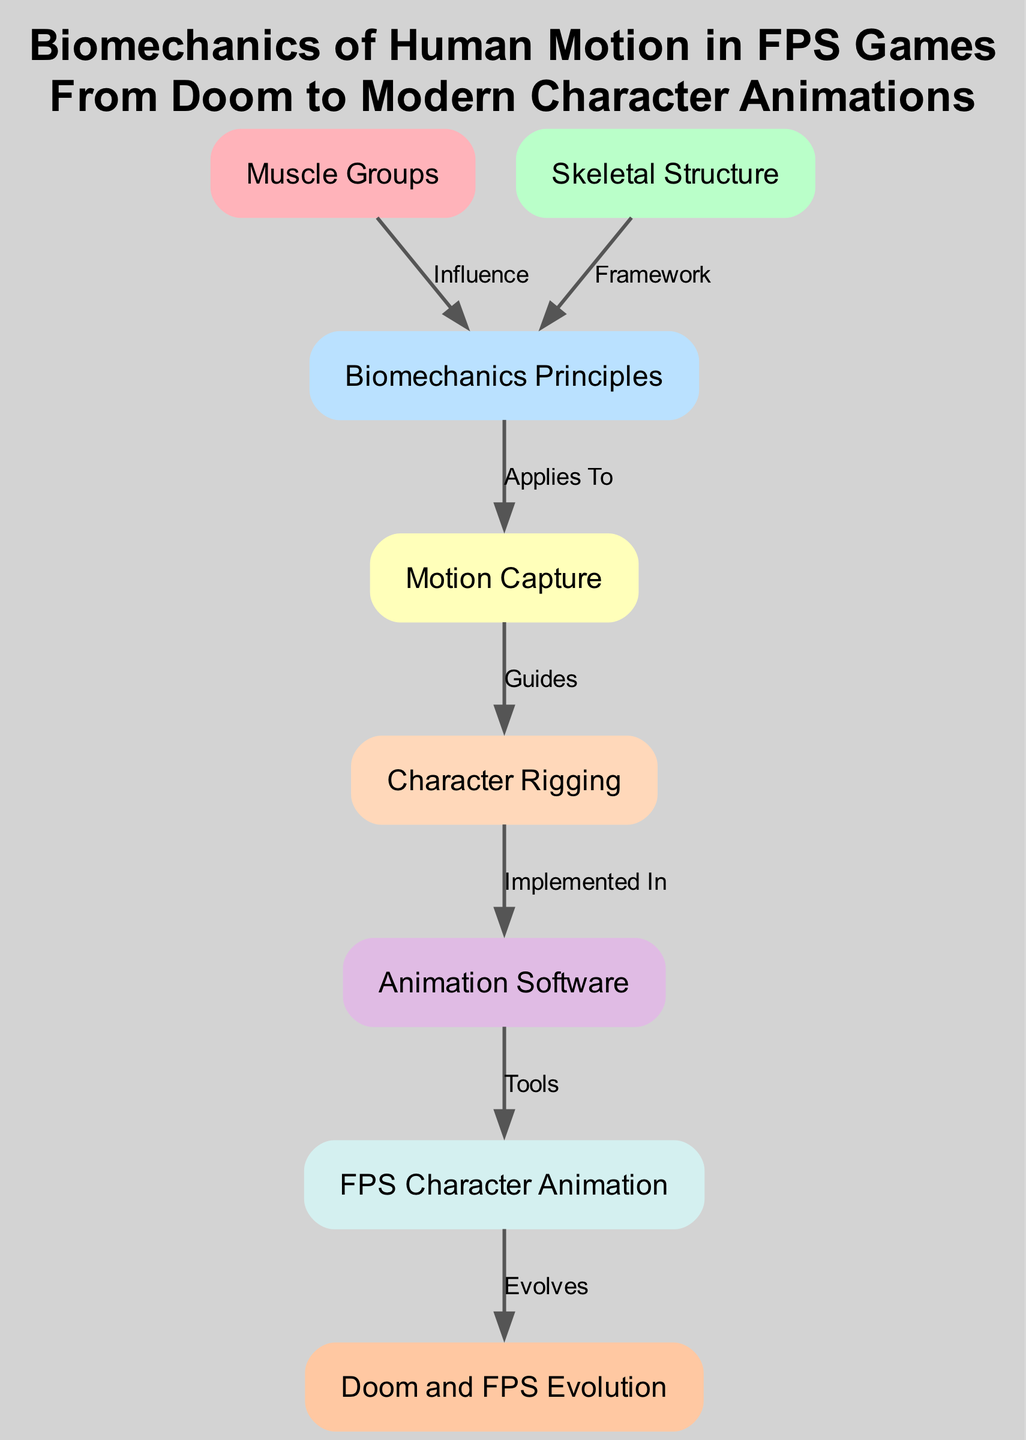What are the major muscle groups involved in human motion? The diagram includes a node labeled "Muscle Groups," indicating that it represents the major muscle groups involved in human motion.
Answer: Muscle Groups How is skeletal structure related to biomechanics? The edge from "Skeletal Structure" to "Biomechanics Principles" labeled "Framework" indicates that the skeletal structure provides the framework for understanding biomechanics.
Answer: Framework What technology applies to the study of biomechanics? The diagram shows an edge indicating that "Motion Capture" is a technology that applies to "Biomechanics Principles," highlighting its relevance in recording human movement for analysis.
Answer: Motion Capture Which software is implemented in character rigging? The edge from "Rigging" to "Animation Software" indicates this relationship, meaning that the process of rigging is realized through specific animation software tools.
Answer: Animation Software In what way does FPS character animation evolve? The edge from "FPS Character Animation" to "Doom Evolution" indicates that character animations in FPS games evolve from earlier games like Doom, highlighting the historical development of animation techniques.
Answer: Evolves How many nodes are represented in this diagram? The diagram contains eight nodes, each representing different concepts related to biomechanics and character animation in FPS games.
Answer: Eight What influences biomechanics principles directly? There are two edges indicating influence or framework: one from "Muscle Groups" and another from "Skeletal Structure," both of which provide foundational understanding for biomechanics principles.
Answer: Muscle Groups and Skeletal Structure Which node guides the rigging process? The node labeled "Motion Capture" guides the "Rigging" process, as indicated by the directed edge labeled "Guides" connecting the two nodes.
Answer: Motion Capture What graphical shape is used for the nodes? All nodes in the diagram are represented using the box shape as specified in the code for styling the graph.
Answer: Box 